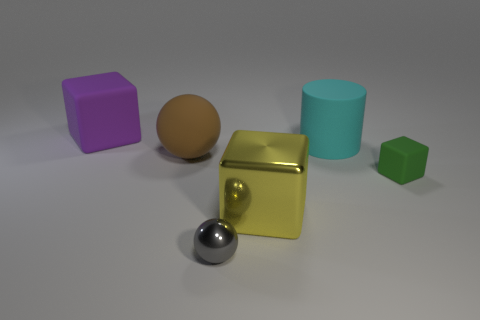How many other objects are there of the same color as the metal cube?
Offer a very short reply. 0. Is the tiny thing right of the yellow cube made of the same material as the big cube that is to the right of the gray metallic object?
Make the answer very short. No. What is the size of the matte block on the right side of the big cyan rubber object?
Provide a succinct answer. Small. There is a small object that is the same shape as the large metallic thing; what is its material?
Give a very brief answer. Rubber. There is a large matte thing that is behind the big matte cylinder; what is its shape?
Make the answer very short. Cube. How many tiny green matte objects are the same shape as the large yellow thing?
Make the answer very short. 1. Are there an equal number of green matte blocks that are behind the small green rubber block and tiny objects behind the metallic ball?
Keep it short and to the point. No. Are there any brown spheres made of the same material as the large purple thing?
Your response must be concise. Yes. Does the small gray sphere have the same material as the yellow cube?
Ensure brevity in your answer.  Yes. What number of gray objects are spheres or tiny things?
Keep it short and to the point. 1. 